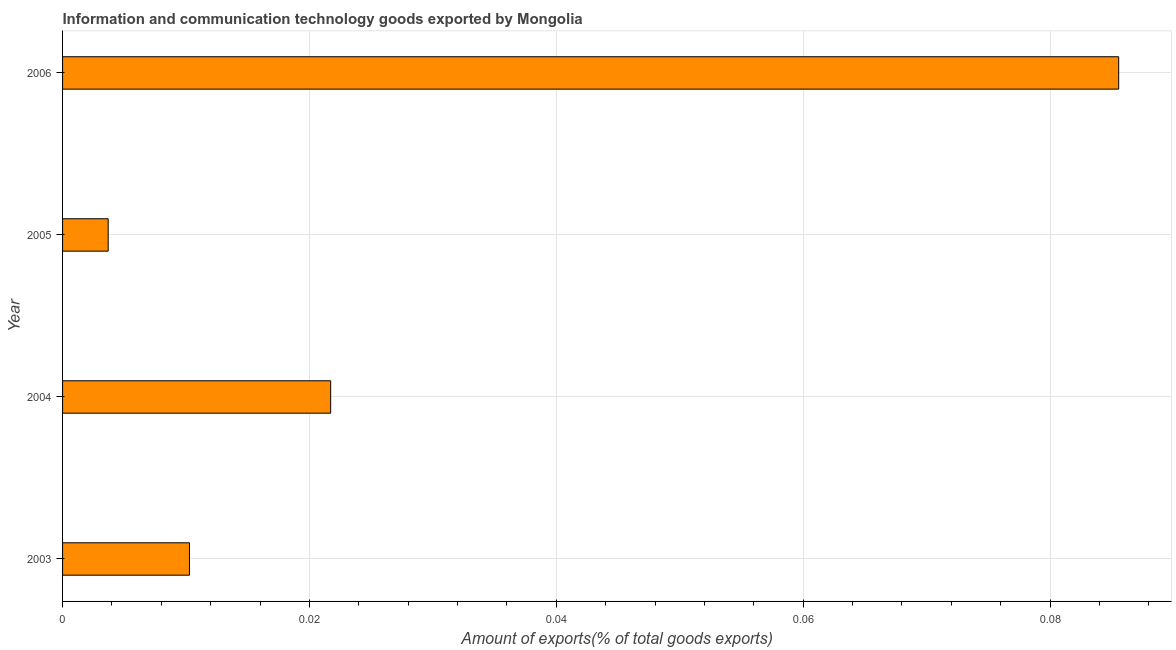Does the graph contain any zero values?
Your response must be concise. No. What is the title of the graph?
Ensure brevity in your answer.  Information and communication technology goods exported by Mongolia. What is the label or title of the X-axis?
Offer a very short reply. Amount of exports(% of total goods exports). What is the amount of ict goods exports in 2004?
Your answer should be compact. 0.02. Across all years, what is the maximum amount of ict goods exports?
Offer a very short reply. 0.09. Across all years, what is the minimum amount of ict goods exports?
Your response must be concise. 0. In which year was the amount of ict goods exports maximum?
Ensure brevity in your answer.  2006. What is the sum of the amount of ict goods exports?
Make the answer very short. 0.12. What is the difference between the amount of ict goods exports in 2005 and 2006?
Your response must be concise. -0.08. What is the average amount of ict goods exports per year?
Offer a very short reply. 0.03. What is the median amount of ict goods exports?
Provide a succinct answer. 0.02. In how many years, is the amount of ict goods exports greater than 0.02 %?
Offer a terse response. 2. What is the ratio of the amount of ict goods exports in 2003 to that in 2006?
Keep it short and to the point. 0.12. What is the difference between the highest and the second highest amount of ict goods exports?
Ensure brevity in your answer.  0.06. Is the sum of the amount of ict goods exports in 2004 and 2006 greater than the maximum amount of ict goods exports across all years?
Your answer should be very brief. Yes. What is the difference between the highest and the lowest amount of ict goods exports?
Make the answer very short. 0.08. In how many years, is the amount of ict goods exports greater than the average amount of ict goods exports taken over all years?
Keep it short and to the point. 1. How many bars are there?
Provide a succinct answer. 4. What is the Amount of exports(% of total goods exports) in 2003?
Your response must be concise. 0.01. What is the Amount of exports(% of total goods exports) of 2004?
Keep it short and to the point. 0.02. What is the Amount of exports(% of total goods exports) of 2005?
Your answer should be compact. 0. What is the Amount of exports(% of total goods exports) in 2006?
Your answer should be very brief. 0.09. What is the difference between the Amount of exports(% of total goods exports) in 2003 and 2004?
Your answer should be very brief. -0.01. What is the difference between the Amount of exports(% of total goods exports) in 2003 and 2005?
Provide a short and direct response. 0.01. What is the difference between the Amount of exports(% of total goods exports) in 2003 and 2006?
Provide a succinct answer. -0.08. What is the difference between the Amount of exports(% of total goods exports) in 2004 and 2005?
Offer a terse response. 0.02. What is the difference between the Amount of exports(% of total goods exports) in 2004 and 2006?
Provide a succinct answer. -0.06. What is the difference between the Amount of exports(% of total goods exports) in 2005 and 2006?
Give a very brief answer. -0.08. What is the ratio of the Amount of exports(% of total goods exports) in 2003 to that in 2004?
Make the answer very short. 0.47. What is the ratio of the Amount of exports(% of total goods exports) in 2003 to that in 2005?
Give a very brief answer. 2.78. What is the ratio of the Amount of exports(% of total goods exports) in 2003 to that in 2006?
Give a very brief answer. 0.12. What is the ratio of the Amount of exports(% of total goods exports) in 2004 to that in 2005?
Provide a succinct answer. 5.88. What is the ratio of the Amount of exports(% of total goods exports) in 2004 to that in 2006?
Keep it short and to the point. 0.25. What is the ratio of the Amount of exports(% of total goods exports) in 2005 to that in 2006?
Provide a succinct answer. 0.04. 